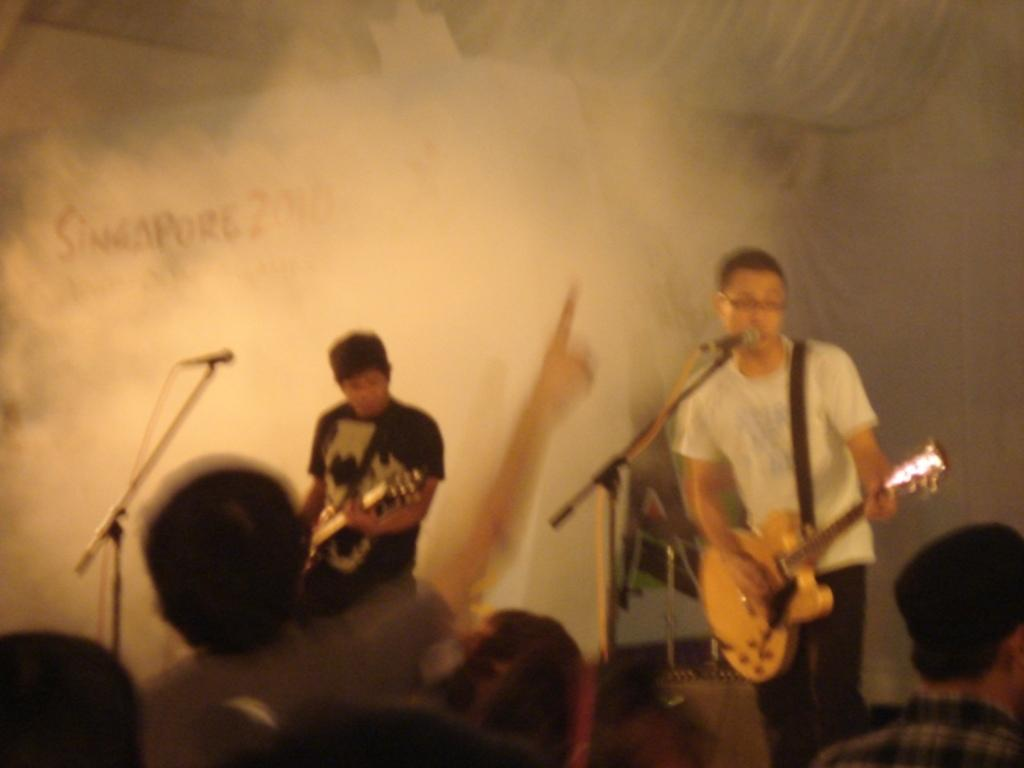What are the 2 people in the image doing? The 2 people in the image are playing guitar. Are there any other people in the image besides the ones playing guitar? Yes, there are people standing and watching them. What time of day is it at the zoo in the image? There is no zoo present in the image, and therefore no specific time of day can be determined. 